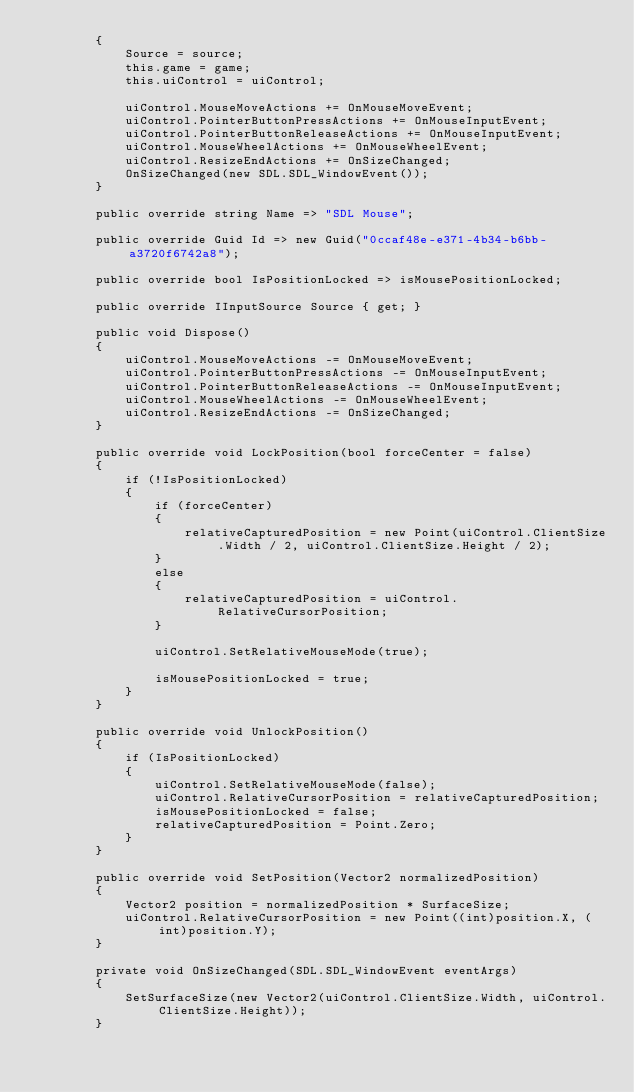<code> <loc_0><loc_0><loc_500><loc_500><_C#_>        {
            Source = source;
            this.game = game;
            this.uiControl = uiControl;
            
            uiControl.MouseMoveActions += OnMouseMoveEvent;
            uiControl.PointerButtonPressActions += OnMouseInputEvent;
            uiControl.PointerButtonReleaseActions += OnMouseInputEvent;
            uiControl.MouseWheelActions += OnMouseWheelEvent;
            uiControl.ResizeEndActions += OnSizeChanged;
            OnSizeChanged(new SDL.SDL_WindowEvent());
        }
        
        public override string Name => "SDL Mouse";

        public override Guid Id => new Guid("0ccaf48e-e371-4b34-b6bb-a3720f6742a8");

        public override bool IsPositionLocked => isMousePositionLocked;

        public override IInputSource Source { get; }

        public void Dispose()
        {
            uiControl.MouseMoveActions -= OnMouseMoveEvent;
            uiControl.PointerButtonPressActions -= OnMouseInputEvent;
            uiControl.PointerButtonReleaseActions -= OnMouseInputEvent;
            uiControl.MouseWheelActions -= OnMouseWheelEvent;
            uiControl.ResizeEndActions -= OnSizeChanged;
        }

        public override void LockPosition(bool forceCenter = false)
        {
            if (!IsPositionLocked)
            {
                if (forceCenter)
                {
                    relativeCapturedPosition = new Point(uiControl.ClientSize.Width / 2, uiControl.ClientSize.Height / 2);
                }
                else
                {
                    relativeCapturedPosition = uiControl.RelativeCursorPosition;
                }

                uiControl.SetRelativeMouseMode(true);

                isMousePositionLocked = true;
            }
        }

        public override void UnlockPosition()
        {
            if (IsPositionLocked)
            {
                uiControl.SetRelativeMouseMode(false);
                uiControl.RelativeCursorPosition = relativeCapturedPosition;
                isMousePositionLocked = false;
                relativeCapturedPosition = Point.Zero;
            }
        }

        public override void SetPosition(Vector2 normalizedPosition)
        {
            Vector2 position = normalizedPosition * SurfaceSize;
            uiControl.RelativeCursorPosition = new Point((int)position.X, (int)position.Y);
        }
        
        private void OnSizeChanged(SDL.SDL_WindowEvent eventArgs)
        {
            SetSurfaceSize(new Vector2(uiControl.ClientSize.Width, uiControl.ClientSize.Height));
        }
</code> 